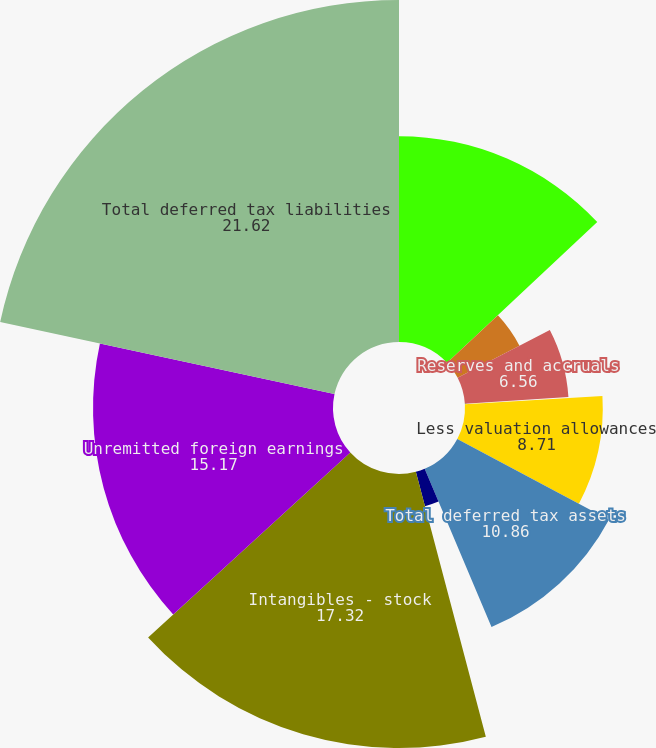Convert chart. <chart><loc_0><loc_0><loc_500><loc_500><pie_chart><fcel>Tax loss and credit<fcel>Pension<fcel>Reserves and accruals<fcel>Other<fcel>Less valuation allowances<fcel>Total deferred tax assets<fcel>Property plant and equipment<fcel>Intangibles - stock<fcel>Unremitted foreign earnings<fcel>Total deferred tax liabilities<nl><fcel>13.01%<fcel>4.4%<fcel>6.56%<fcel>0.1%<fcel>8.71%<fcel>10.86%<fcel>2.25%<fcel>17.32%<fcel>15.17%<fcel>21.62%<nl></chart> 